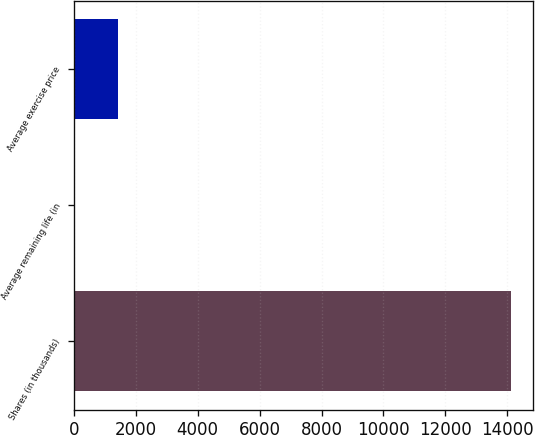<chart> <loc_0><loc_0><loc_500><loc_500><bar_chart><fcel>Shares (in thousands)<fcel>Average remaining life (in<fcel>Average exercise price<nl><fcel>14134<fcel>8.1<fcel>1420.69<nl></chart> 